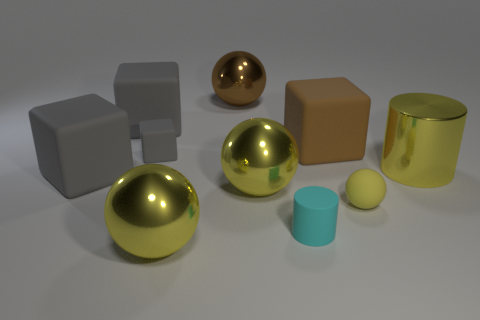Subtract all yellow balls. How many were subtracted if there are1yellow balls left? 2 Subtract all yellow cylinders. How many gray cubes are left? 3 Subtract 1 cubes. How many cubes are left? 3 Subtract all cylinders. How many objects are left? 8 Subtract 0 red blocks. How many objects are left? 10 Subtract all tiny purple matte blocks. Subtract all balls. How many objects are left? 6 Add 5 tiny rubber cylinders. How many tiny rubber cylinders are left? 6 Add 8 big cylinders. How many big cylinders exist? 9 